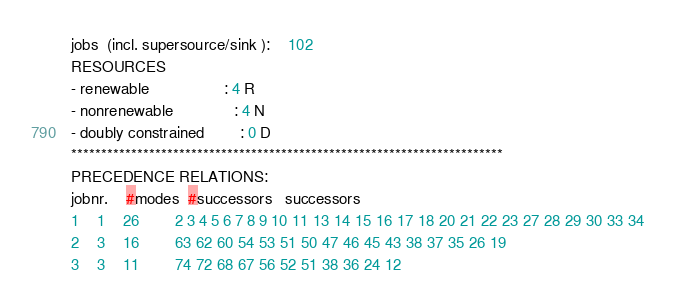Convert code to text. <code><loc_0><loc_0><loc_500><loc_500><_ObjectiveC_>jobs  (incl. supersource/sink ):	102
RESOURCES
- renewable                 : 4 R
- nonrenewable              : 4 N
- doubly constrained        : 0 D
************************************************************************
PRECEDENCE RELATIONS:
jobnr.    #modes  #successors   successors
1	1	26		2 3 4 5 6 7 8 9 10 11 13 14 15 16 17 18 20 21 22 23 27 28 29 30 33 34 
2	3	16		63 62 60 54 53 51 50 47 46 45 43 38 37 35 26 19 
3	3	11		74 72 68 67 56 52 51 38 36 24 12 </code> 